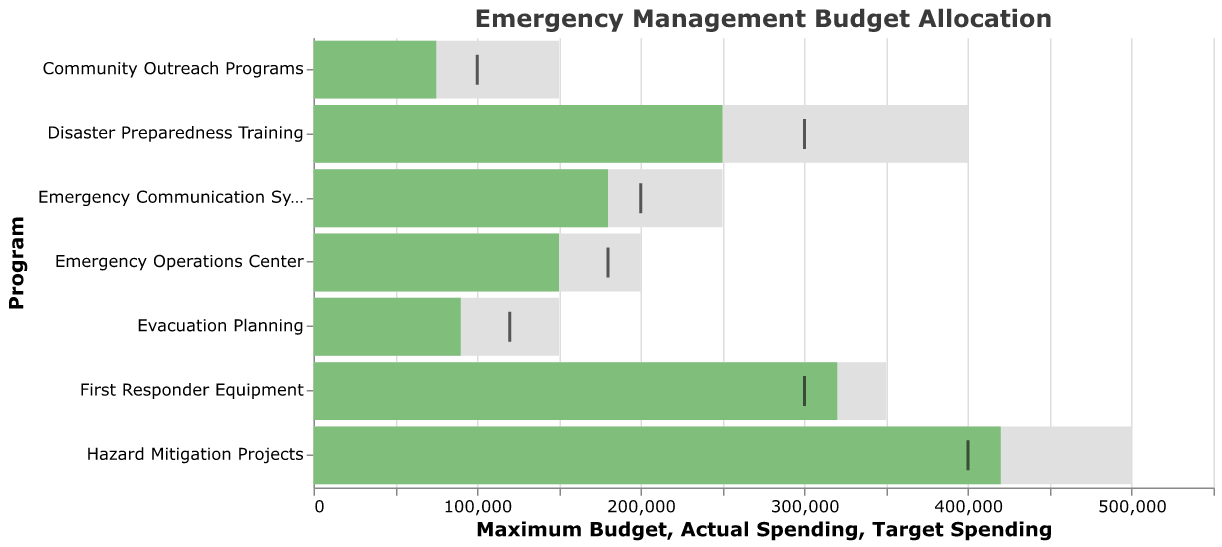What is the title of the figure? The title is written at the top of the figure in bold font. It reads "Emergency Management Budget Allocation."
Answer: Emergency Management Budget Allocation Which program has the highest actual spending? Look for the program whose green bar, representing actual spending, is the longest.
Answer: Hazard Mitigation Projects Which program's actual spending most closely matches its target spending? Compare the green bar (actual spending) with the black tick mark (target spending) for each program. The closest ones will have the green bar nearly touching the black tick mark.
Answer: First Responder Equipment How much more is the maximum budget than the actual spending for Emergency Communication Systems? Find the length of the grey bar (maximum budget) and the green bar (actual spending) for Emergency Communication Systems and subtract the green bar's length from the grey bar's length.
Answer: 70,000 For which programs did the actual spending exceed the target spending? Identify the programs where the green bar (actual spending) extends beyond the black tick mark (target spending).
Answer: First Responder Equipment, Hazard Mitigation Projects What is the difference between the target spending and actual spending for Evacuation Planning? Find the location of the black tick mark (target spending) and compare it with the green bar (actual spending) for Evacuation Planning, then calculate the difference.
Answer: 30,000 Which two programs have the largest disparity between actual spending and maximum budget? Look for the two programs with the longest grey bars (maximum budget) minus the actual spending (green bars) and compare these differences.
Answer: Hazard Mitigation Projects, Disaster Preparedness Training How does the actual spending for the Community Outreach Programs compare to its maximum budget? Compare the length of the green bar (actual spending) to the grey bar (maximum budget) for Community Outreach Programs.
Answer: The actual spending is 50% of the maximum budget What is the sum of the actual spendings for Disaster Preparedness Training and Emergency Communication Systems? Add the numerical values of actual spending for Disaster Preparedness Training (250,000) and Emergency Communication Systems (180,000).
Answer: 430,000 Which program shows the largest underspending compared to its target? Determine which program has the black tick mark (target spending) significantly higher than the green bar (actual spending).
Answer: Disaster Preparedness Training 